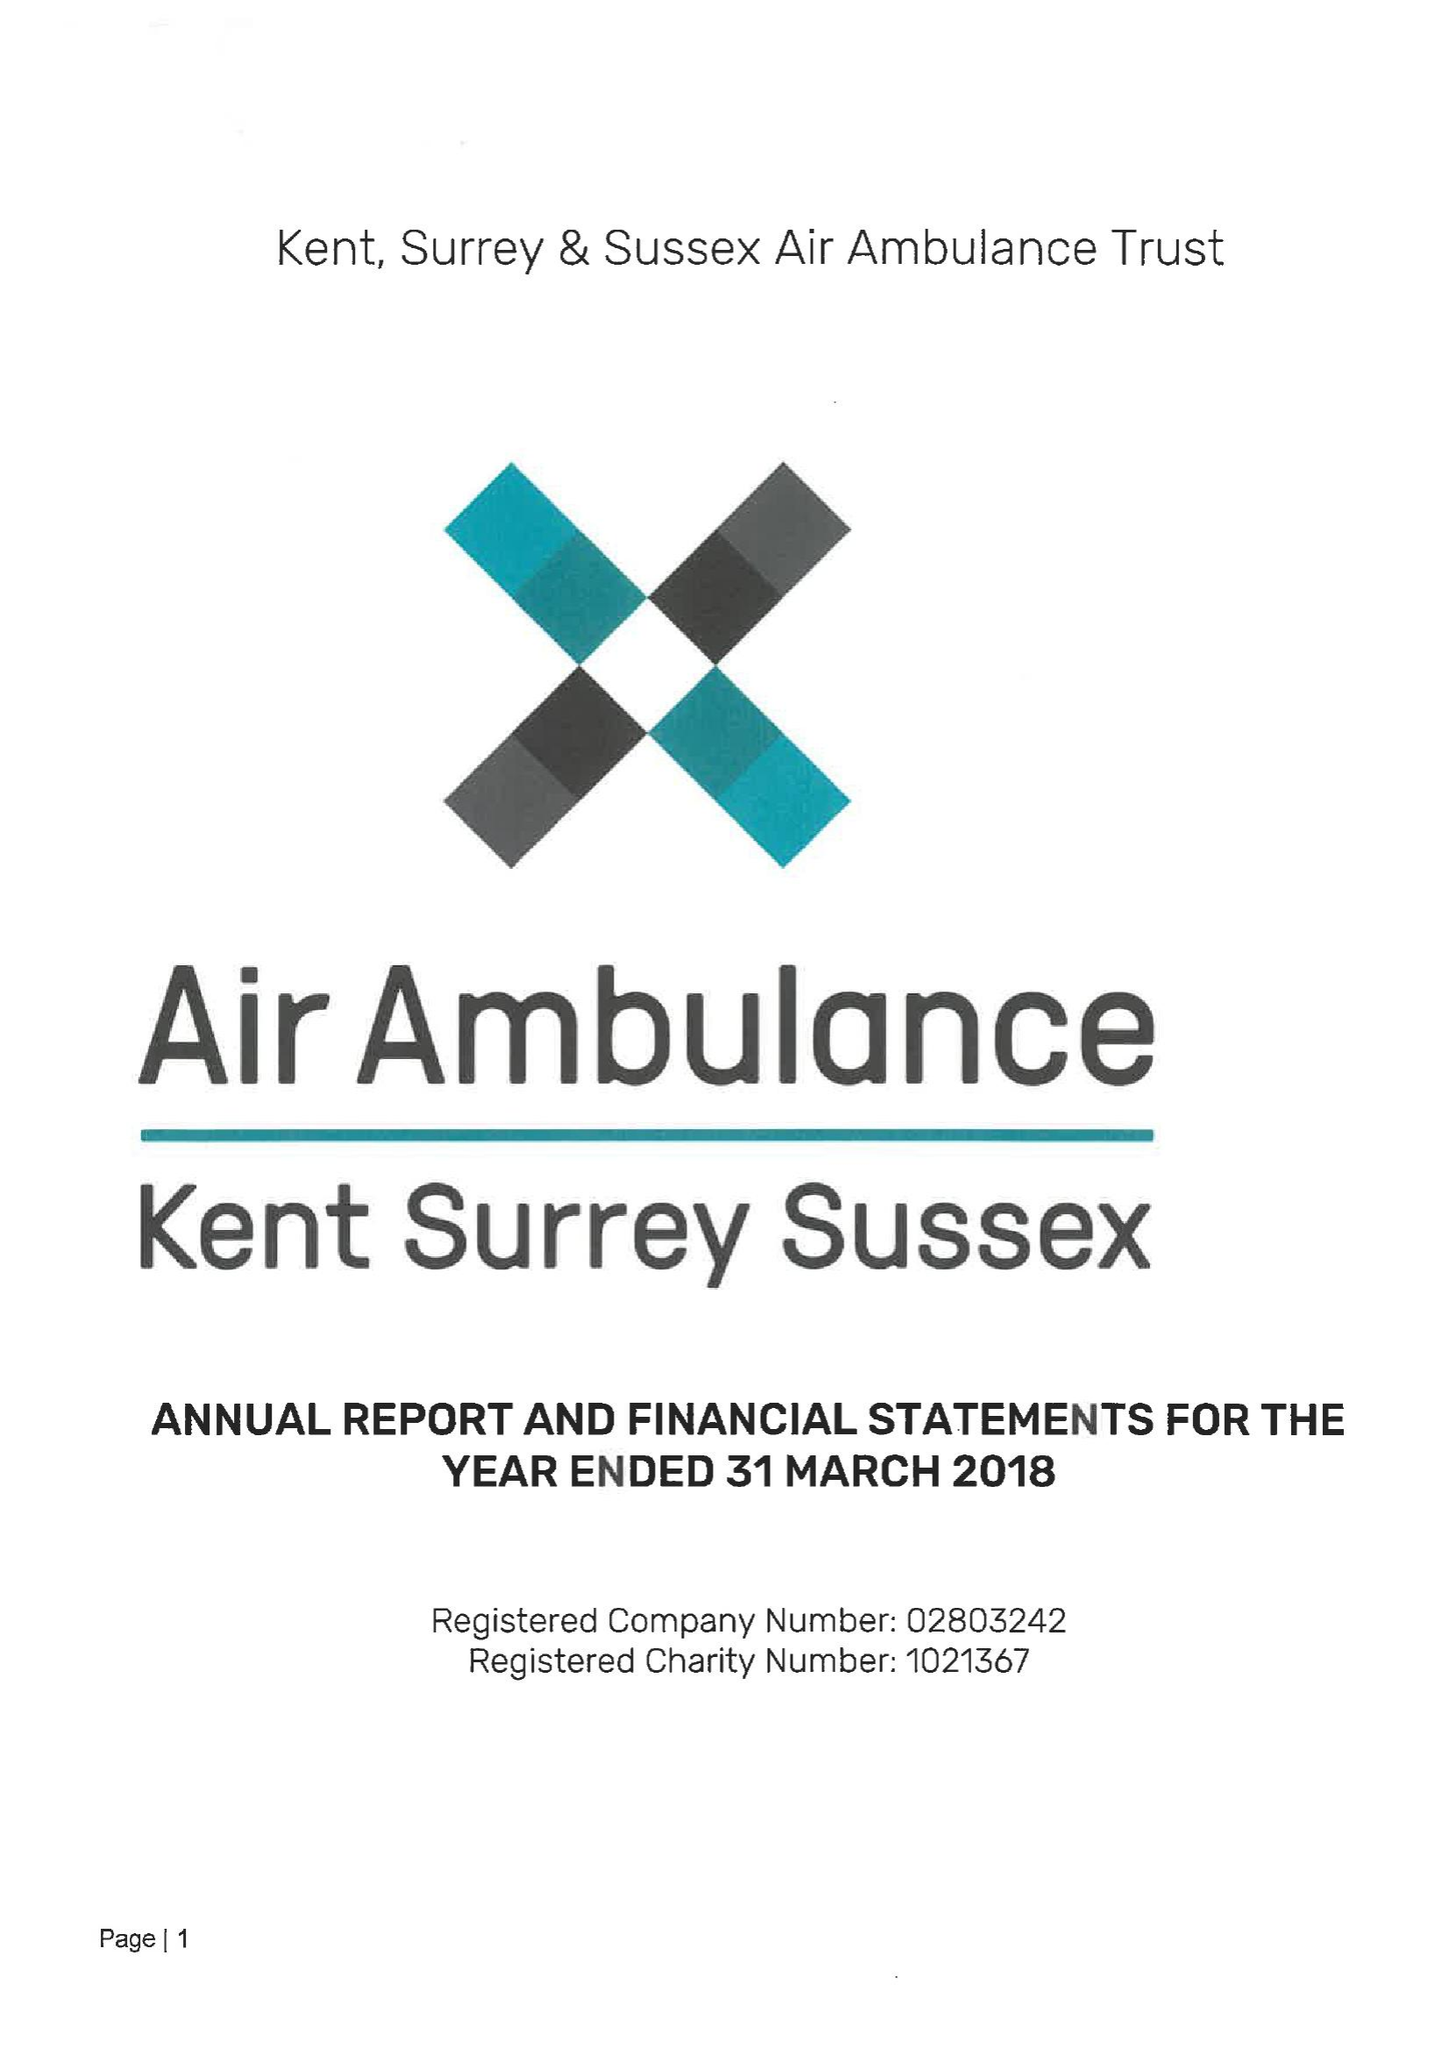What is the value for the income_annually_in_british_pounds?
Answer the question using a single word or phrase. 14112723.00 